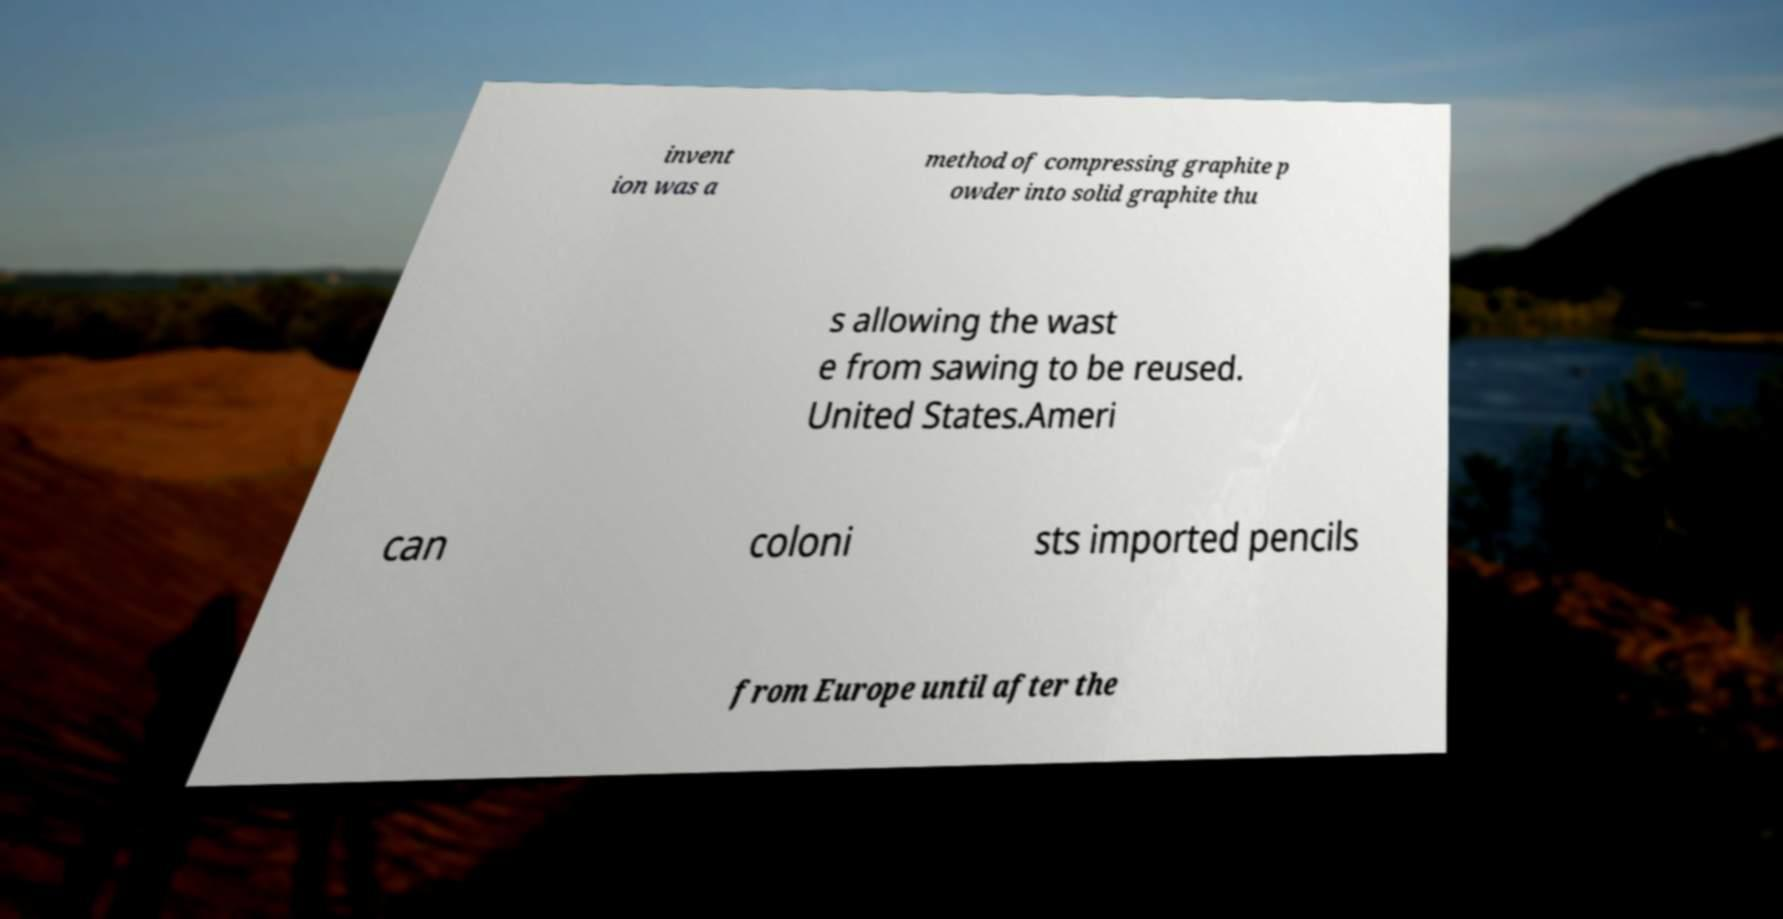Could you extract and type out the text from this image? invent ion was a method of compressing graphite p owder into solid graphite thu s allowing the wast e from sawing to be reused. United States.Ameri can coloni sts imported pencils from Europe until after the 